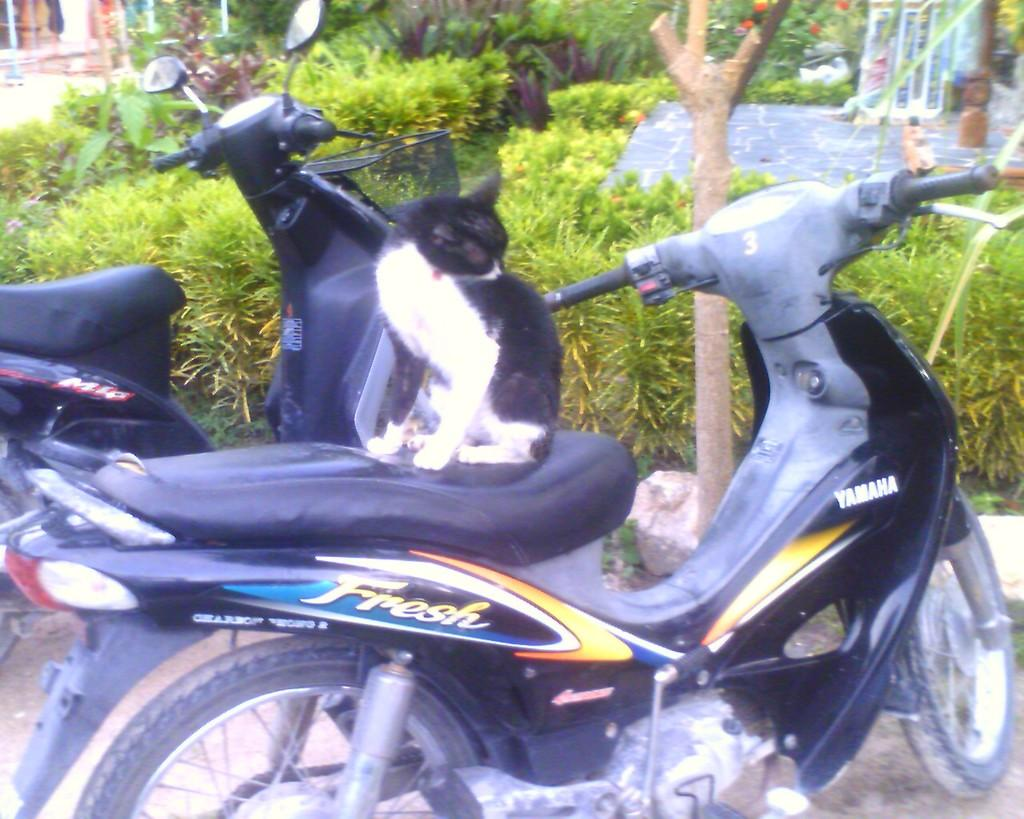How many bikes can be seen in the image? There are two bikes in the image. What is the cat doing in the image? A cat is sitting on one of the bikes. What can be seen in the background of the image? There is a garden visible in the image. What color is the kite flying in the image? There is no kite present in the image. How does the voice of the person holding the tray sound in the image? There is no tray or person holding a tray present in the image. 